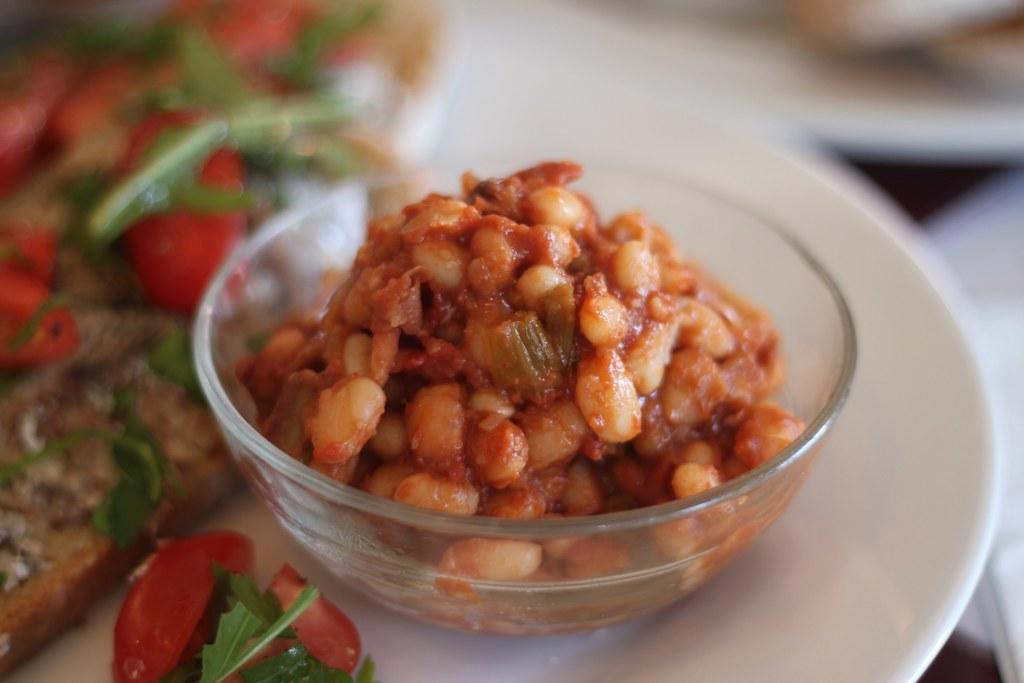What is on the plate that is visible in the image? There is a plate with food in the image. What type of food is in the bowl in the image? There is a bowl full of corn curry in the image. Where is the giraffe standing in the image? There is no giraffe present in the image. What type of fruit is visible on the plate in the image? There is no fruit visible on the plate in the image; it contains food, but the specific type of food is not mentioned. 